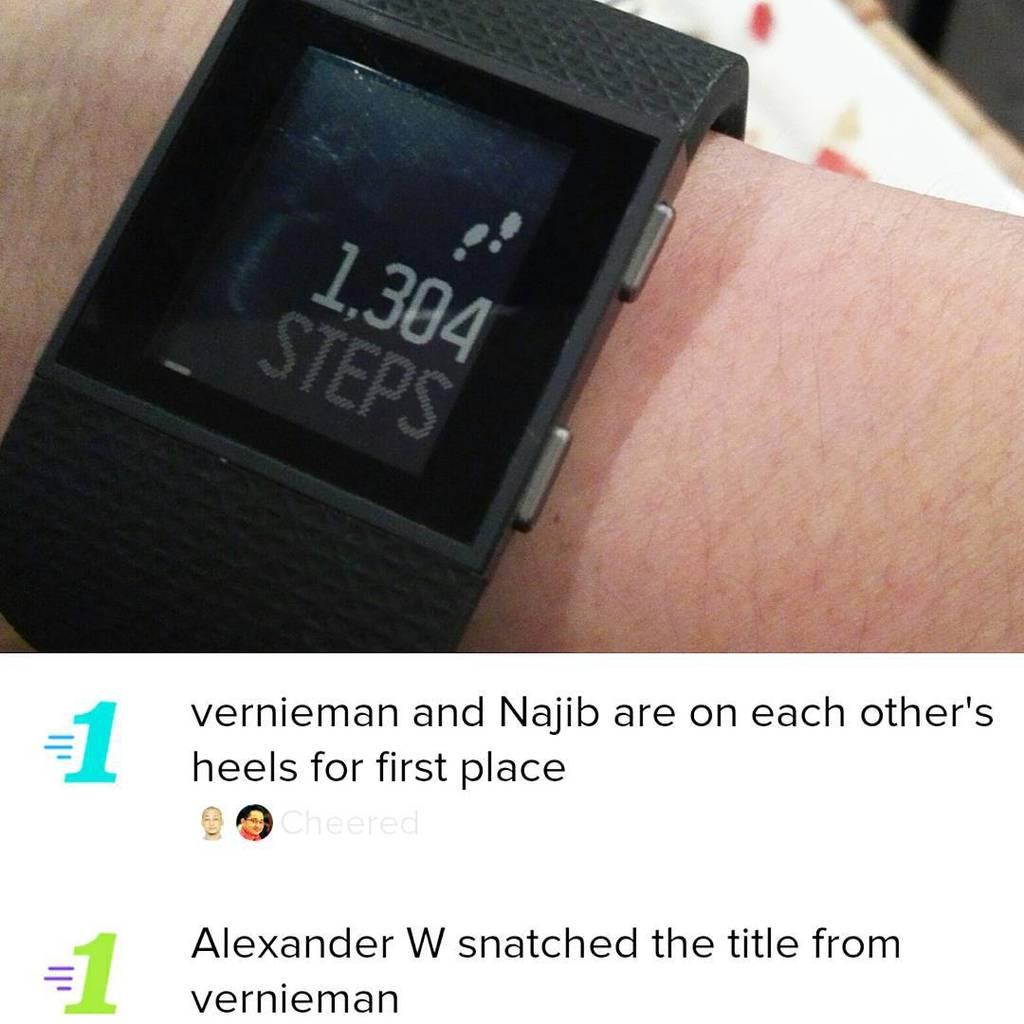Who many steps have been taken?
Make the answer very short. 1304. 